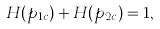<formula> <loc_0><loc_0><loc_500><loc_500>H ( p _ { 1 c } ) + H ( p _ { 2 c } ) = 1 ,</formula> 